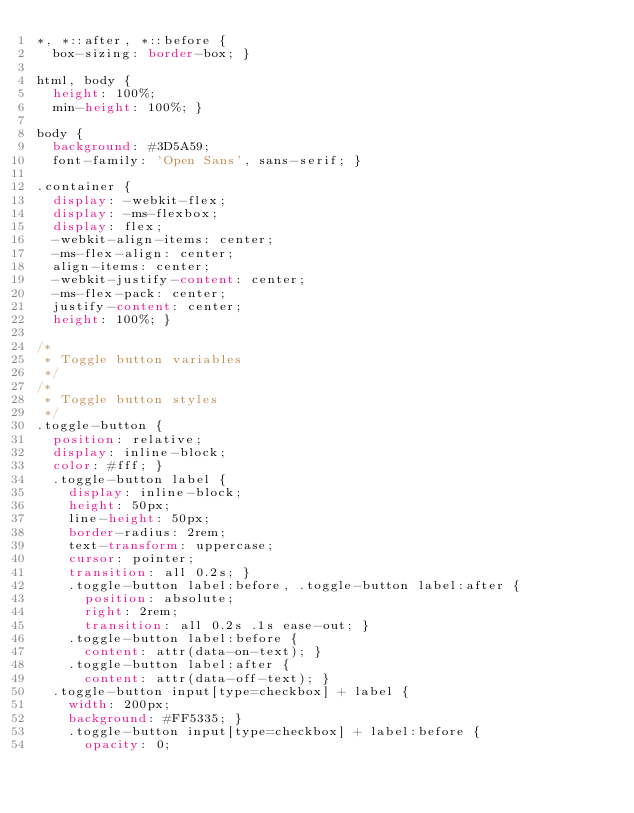<code> <loc_0><loc_0><loc_500><loc_500><_CSS_>*, *::after, *::before {
  box-sizing: border-box; }

html, body {
  height: 100%;
  min-height: 100%; }

body {
  background: #3D5A59;
  font-family: 'Open Sans', sans-serif; }

.container {
  display: -webkit-flex;
  display: -ms-flexbox;
  display: flex;
  -webkit-align-items: center;
  -ms-flex-align: center;
  align-items: center;
  -webkit-justify-content: center;
  -ms-flex-pack: center;
  justify-content: center;
  height: 100%; }

/*
 * Toggle button variables
 */
/*
 * Toggle button styles
 */
.toggle-button {
  position: relative;
  display: inline-block;
  color: #fff; }
  .toggle-button label {
    display: inline-block;
    height: 50px;
    line-height: 50px;
    border-radius: 2rem;
    text-transform: uppercase;
    cursor: pointer;
    transition: all 0.2s; }
    .toggle-button label:before, .toggle-button label:after {
      position: absolute;
      right: 2rem;
      transition: all 0.2s .1s ease-out; }
    .toggle-button label:before {
      content: attr(data-on-text); }
    .toggle-button label:after {
      content: attr(data-off-text); }
  .toggle-button input[type=checkbox] + label {
    width: 200px;
    background: #FF5335; }
    .toggle-button input[type=checkbox] + label:before {
      opacity: 0;</code> 